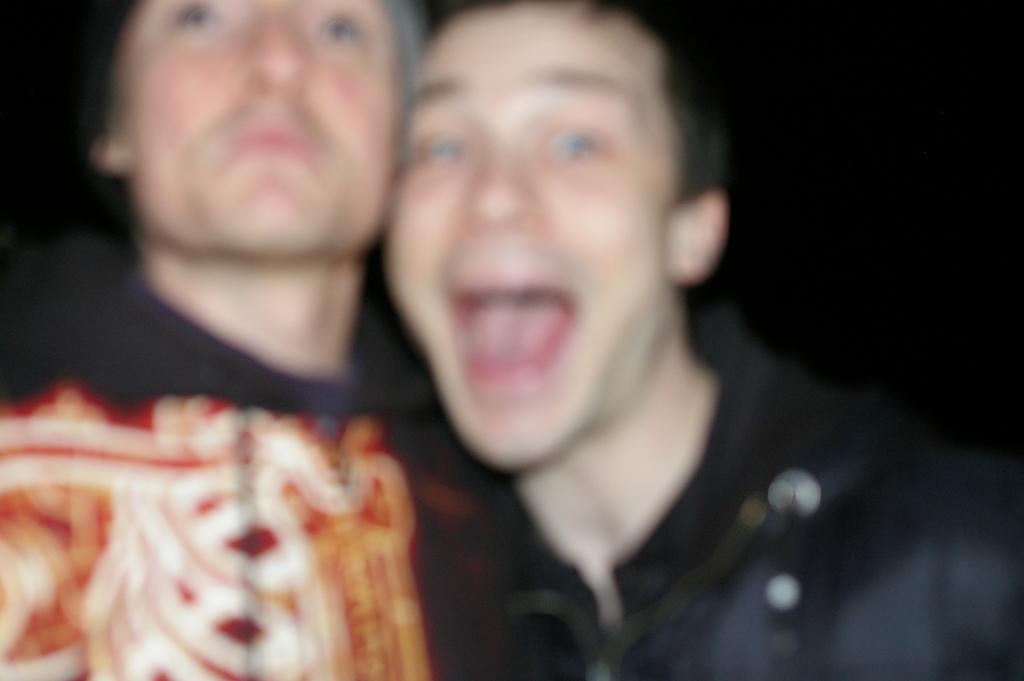What can be observed about the quality of the image? The image is blurry. How many people are present in the image? There are two persons in the image. What type of verse can be heard being recited by the cows in the image? There are no cows present in the image, and therefore no verses can be heard. How can the two persons in the image be helped to improve the quality of the image? The image quality cannot be improved by helping the people in the image, as the blurriness is a characteristic of the image itself. 